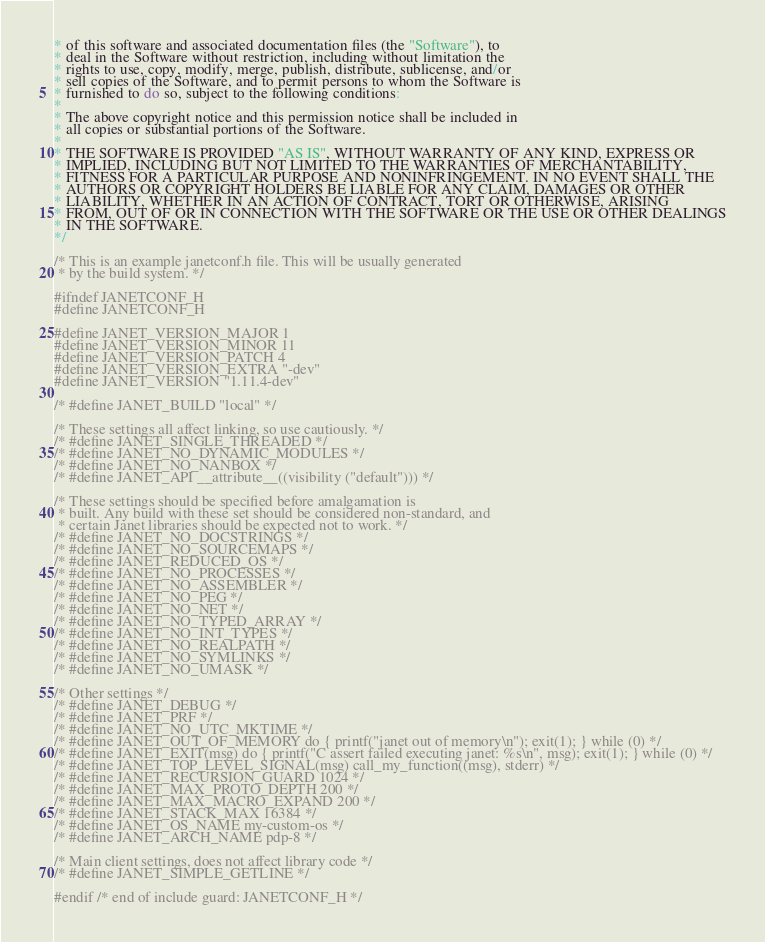Convert code to text. <code><loc_0><loc_0><loc_500><loc_500><_C_>* of this software and associated documentation files (the "Software"), to
* deal in the Software without restriction, including without limitation the
* rights to use, copy, modify, merge, publish, distribute, sublicense, and/or
* sell copies of the Software, and to permit persons to whom the Software is
* furnished to do so, subject to the following conditions:
*
* The above copyright notice and this permission notice shall be included in
* all copies or substantial portions of the Software.
*
* THE SOFTWARE IS PROVIDED "AS IS", WITHOUT WARRANTY OF ANY KIND, EXPRESS OR
* IMPLIED, INCLUDING BUT NOT LIMITED TO THE WARRANTIES OF MERCHANTABILITY,
* FITNESS FOR A PARTICULAR PURPOSE AND NONINFRINGEMENT. IN NO EVENT SHALL THE
* AUTHORS OR COPYRIGHT HOLDERS BE LIABLE FOR ANY CLAIM, DAMAGES OR OTHER
* LIABILITY, WHETHER IN AN ACTION OF CONTRACT, TORT OR OTHERWISE, ARISING
* FROM, OUT OF OR IN CONNECTION WITH THE SOFTWARE OR THE USE OR OTHER DEALINGS
* IN THE SOFTWARE.
*/

/* This is an example janetconf.h file. This will be usually generated
 * by the build system. */

#ifndef JANETCONF_H
#define JANETCONF_H

#define JANET_VERSION_MAJOR 1
#define JANET_VERSION_MINOR 11
#define JANET_VERSION_PATCH 4
#define JANET_VERSION_EXTRA "-dev"
#define JANET_VERSION "1.11.4-dev"

/* #define JANET_BUILD "local" */

/* These settings all affect linking, so use cautiously. */
/* #define JANET_SINGLE_THREADED */
/* #define JANET_NO_DYNAMIC_MODULES */
/* #define JANET_NO_NANBOX */
/* #define JANET_API __attribute__((visibility ("default"))) */

/* These settings should be specified before amalgamation is
 * built. Any build with these set should be considered non-standard, and
 * certain Janet libraries should be expected not to work. */
/* #define JANET_NO_DOCSTRINGS */
/* #define JANET_NO_SOURCEMAPS */
/* #define JANET_REDUCED_OS */
/* #define JANET_NO_PROCESSES */
/* #define JANET_NO_ASSEMBLER */
/* #define JANET_NO_PEG */
/* #define JANET_NO_NET */
/* #define JANET_NO_TYPED_ARRAY */
/* #define JANET_NO_INT_TYPES */
/* #define JANET_NO_REALPATH */
/* #define JANET_NO_SYMLINKS */
/* #define JANET_NO_UMASK */

/* Other settings */
/* #define JANET_DEBUG */
/* #define JANET_PRF */
/* #define JANET_NO_UTC_MKTIME */
/* #define JANET_OUT_OF_MEMORY do { printf("janet out of memory\n"); exit(1); } while (0) */
/* #define JANET_EXIT(msg) do { printf("C assert failed executing janet: %s\n", msg); exit(1); } while (0) */
/* #define JANET_TOP_LEVEL_SIGNAL(msg) call_my_function((msg), stderr) */
/* #define JANET_RECURSION_GUARD 1024 */
/* #define JANET_MAX_PROTO_DEPTH 200 */
/* #define JANET_MAX_MACRO_EXPAND 200 */
/* #define JANET_STACK_MAX 16384 */
/* #define JANET_OS_NAME my-custom-os */
/* #define JANET_ARCH_NAME pdp-8 */

/* Main client settings, does not affect library code */
/* #define JANET_SIMPLE_GETLINE */

#endif /* end of include guard: JANETCONF_H */
</code> 